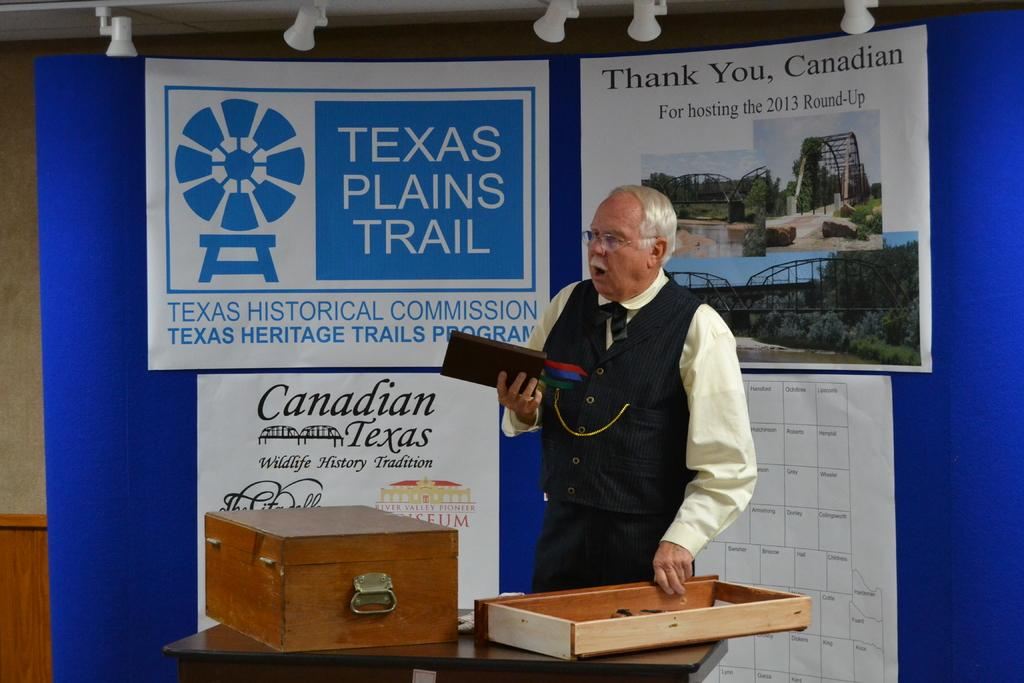Who is the main subject in the image? There is an old man in the image. What is the old man doing in the image? The old man is speaking in the image. What object is the old man holding? The old man is holding a book in the image. What can be seen on the table in the image? There is a wooden box on a table in the image. What is visible in the background of the image? There are posters visible in the background of the image. How many children are holding a yoke in the image? There are no children or yokes present in the image. What type of fork is the old man using to read the book in the image? The old man is not using a fork to read the book in the image; he is simply holding the book. 